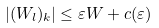Convert formula to latex. <formula><loc_0><loc_0><loc_500><loc_500>| ( W _ { l } ) _ { k } | \leq \varepsilon W + c ( \varepsilon )</formula> 